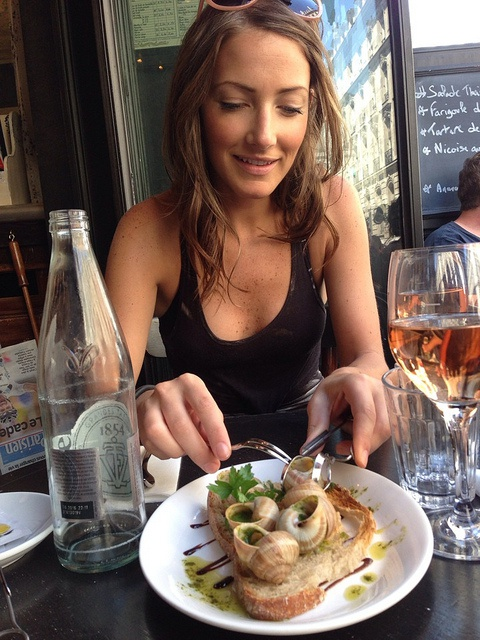Describe the objects in this image and their specific colors. I can see people in maroon, black, brown, and salmon tones, bottle in maroon, gray, black, and darkgray tones, wine glass in maroon, gray, darkgray, and ivory tones, dining table in maroon, black, and gray tones, and sandwich in maroon, gray, olive, and tan tones in this image. 